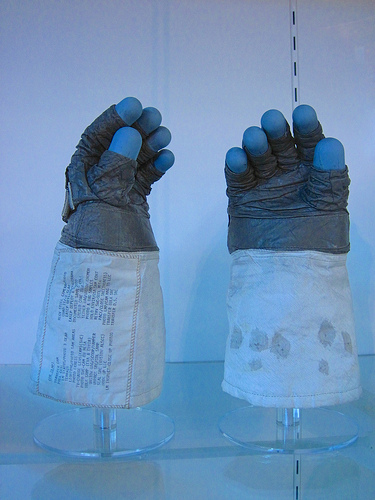<image>
Is the stand on the glove? No. The stand is not positioned on the glove. They may be near each other, but the stand is not supported by or resting on top of the glove. 